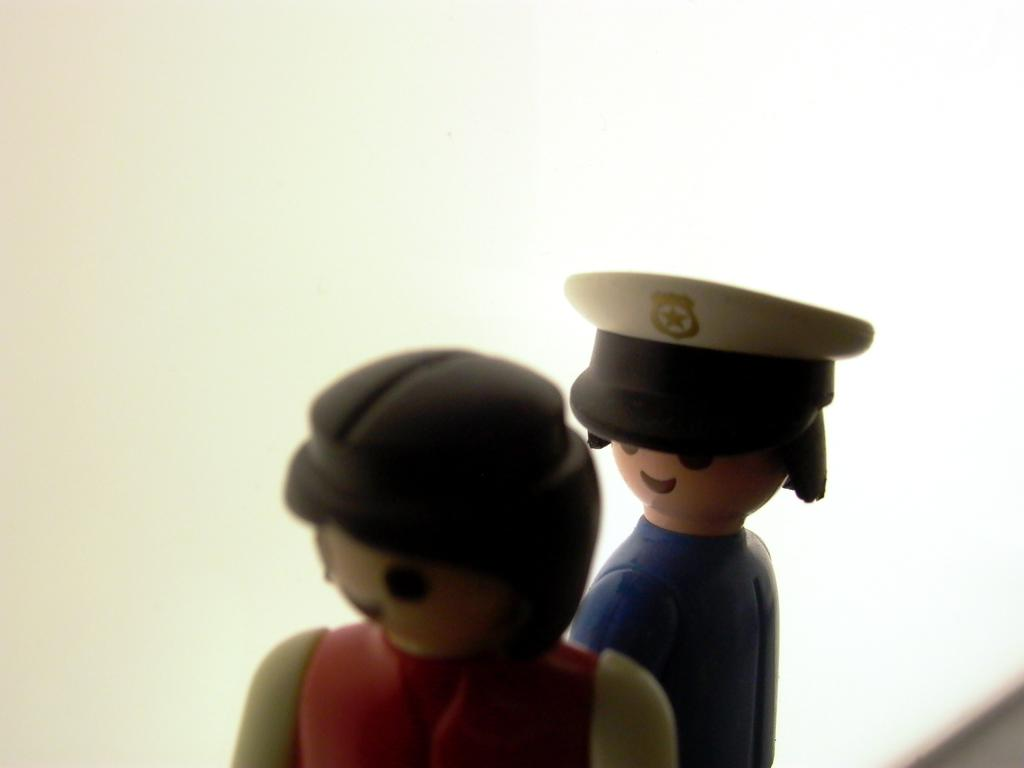What type of objects are in the image? There are human toy statues in the image. How are some of the toy statues positioned? Some of the toy statues are standing. Can you describe the appearance of one of the toy statues? There is a human toy statue wearing a hat. What can be observed about the background of the image? The background of the image is blurred. What time of day is depicted in the image? The time of day cannot be determined from the image, as there are no indications of morning or any other time. 